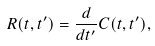Convert formula to latex. <formula><loc_0><loc_0><loc_500><loc_500>R ( t , t ^ { \prime } ) = \frac { d } { d t ^ { \prime } } C ( t , t ^ { \prime } ) ,</formula> 